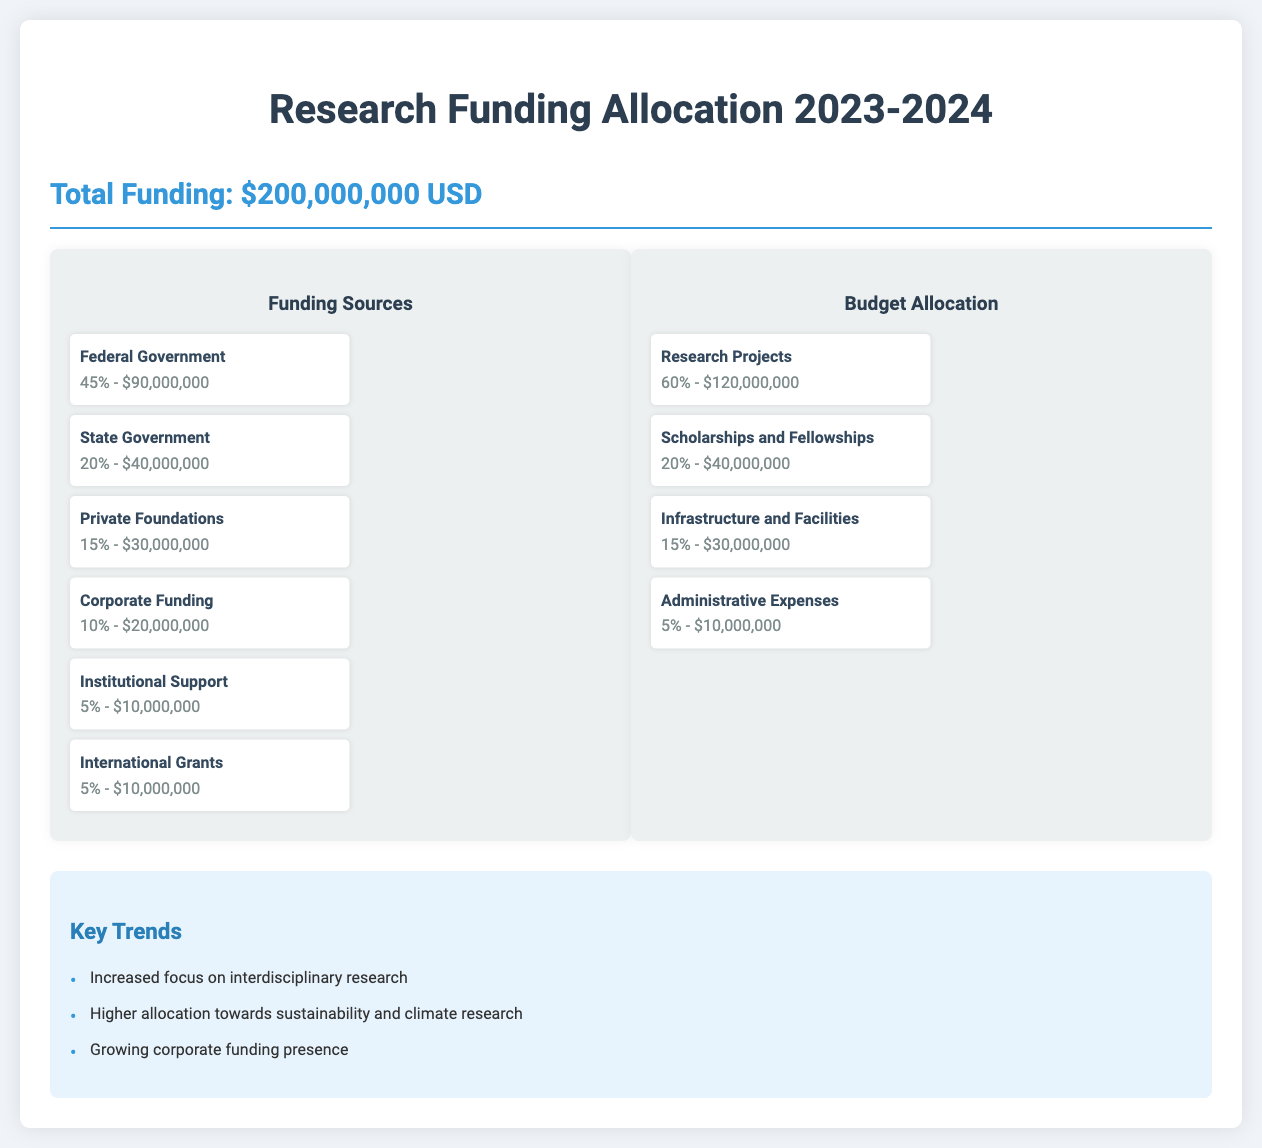What is the total funding? The total funding mentioned in the document is clearly stated at the beginning as $200,000,000 USD.
Answer: $200,000,000 USD What percentage of funding comes from private foundations? The document shows the contribution from private foundations as a percentage of the total funding, which is 15%.
Answer: 15% How much is allocated for research projects? The budget allocation for research projects is detailed in the document, which indicates $120,000,000 as the amount designated for this purpose.
Answer: $120,000,000 What is the percentage for scholarships and fellowships? The document specifies that 20% of the total funding is allocated to scholarships and fellowships.
Answer: 20% Which category has the least funding allocation? By reviewing the budget, administrative expenses are noted as having the least budget allocation, which is $10,000,000.
Answer: Administrative Expenses How much funding is received from the federal government? The federal government’s contribution to the funding is detailed as $90,000,000.
Answer: $90,000,000 What key trend focuses on environmental issues? The document mentions an increased allocation towards sustainability and climate research as a key trend.
Answer: Sustainability and climate research Which funding source constitutes 10% of the total funding? The document states that corporate funding contributes to 10% of the overall funding total.
Answer: Corporate Funding What is the total amount allocated for scholarships and fellowships? The amount specifically allocated for scholarships and fellowships is mentioned as $40,000,000 in the document.
Answer: $40,000,000 